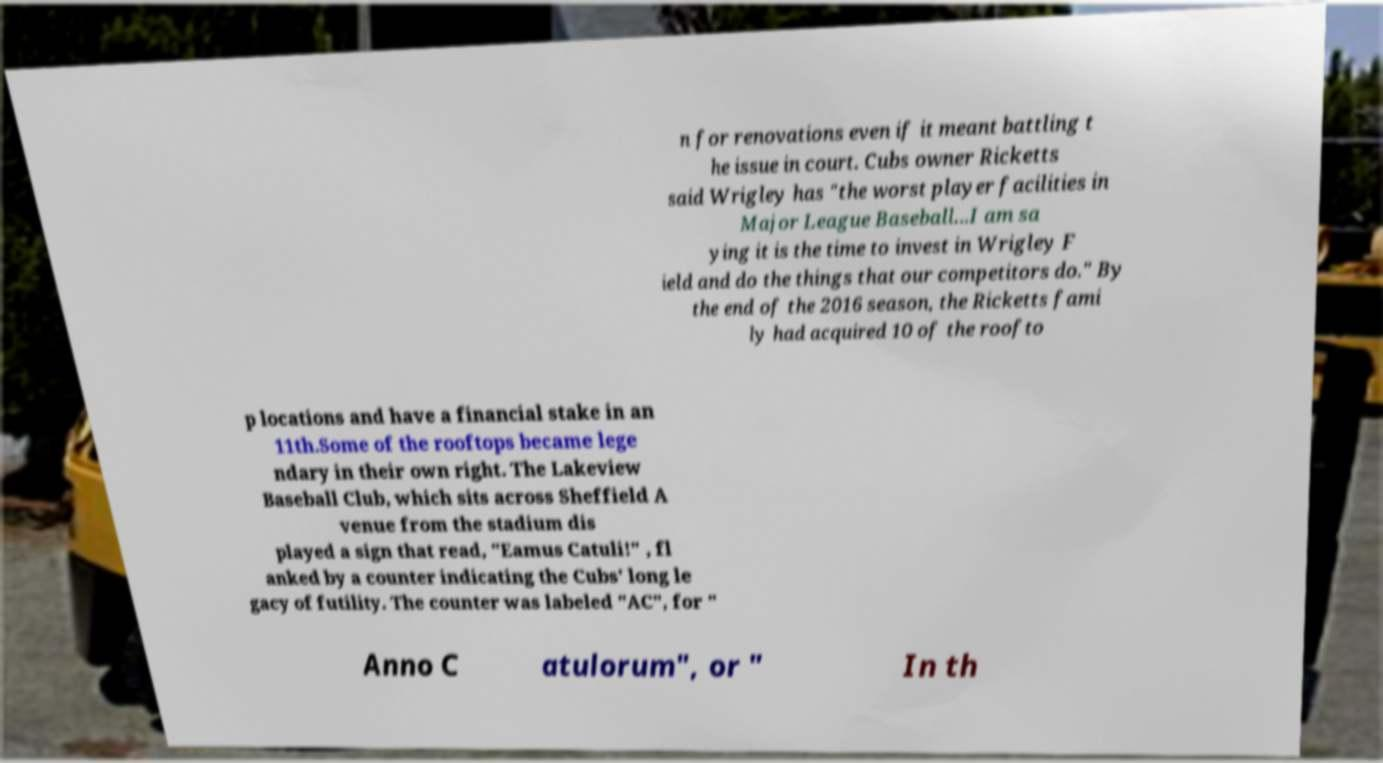What messages or text are displayed in this image? I need them in a readable, typed format. n for renovations even if it meant battling t he issue in court. Cubs owner Ricketts said Wrigley has "the worst player facilities in Major League Baseball...I am sa ying it is the time to invest in Wrigley F ield and do the things that our competitors do." By the end of the 2016 season, the Ricketts fami ly had acquired 10 of the roofto p locations and have a financial stake in an 11th.Some of the rooftops became lege ndary in their own right. The Lakeview Baseball Club, which sits across Sheffield A venue from the stadium dis played a sign that read, "Eamus Catuli!" , fl anked by a counter indicating the Cubs' long le gacy of futility. The counter was labeled "AC", for " Anno C atulorum", or " In th 